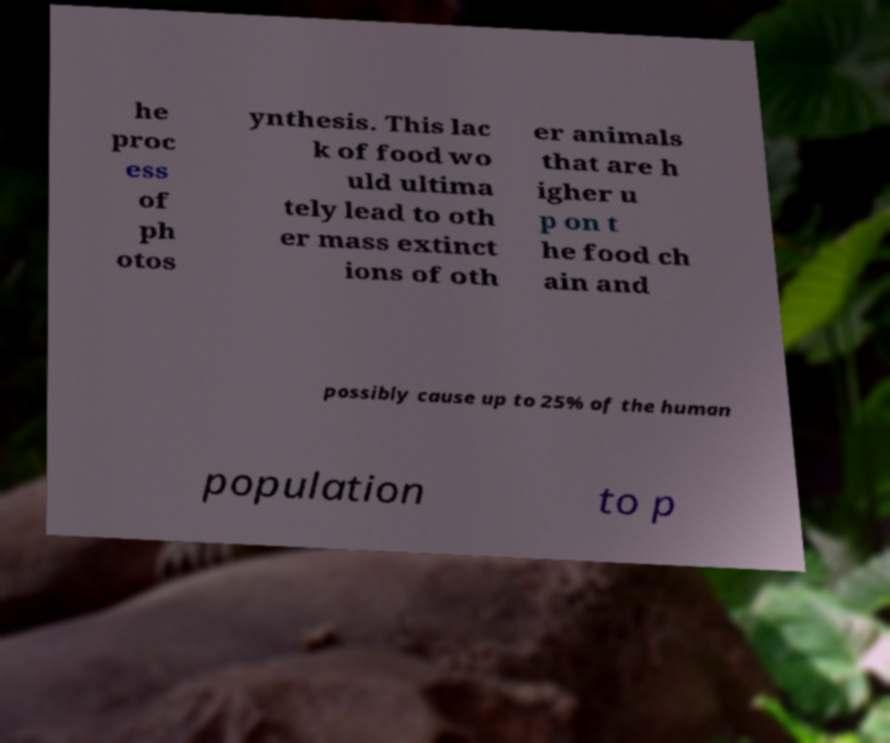Please identify and transcribe the text found in this image. he proc ess of ph otos ynthesis. This lac k of food wo uld ultima tely lead to oth er mass extinct ions of oth er animals that are h igher u p on t he food ch ain and possibly cause up to 25% of the human population to p 